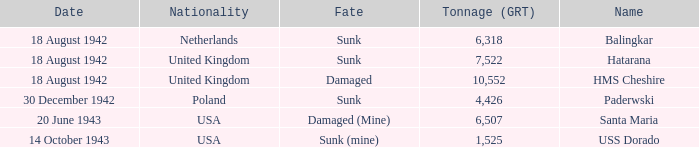What is the nationality of the HMS Cheshire? United Kingdom. 